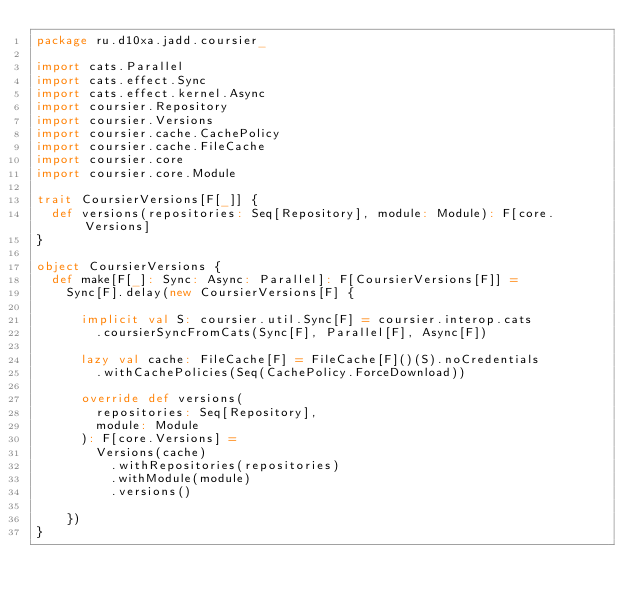<code> <loc_0><loc_0><loc_500><loc_500><_Scala_>package ru.d10xa.jadd.coursier_

import cats.Parallel
import cats.effect.Sync
import cats.effect.kernel.Async
import coursier.Repository
import coursier.Versions
import coursier.cache.CachePolicy
import coursier.cache.FileCache
import coursier.core
import coursier.core.Module

trait CoursierVersions[F[_]] {
  def versions(repositories: Seq[Repository], module: Module): F[core.Versions]
}

object CoursierVersions {
  def make[F[_]: Sync: Async: Parallel]: F[CoursierVersions[F]] =
    Sync[F].delay(new CoursierVersions[F] {

      implicit val S: coursier.util.Sync[F] = coursier.interop.cats
        .coursierSyncFromCats(Sync[F], Parallel[F], Async[F])

      lazy val cache: FileCache[F] = FileCache[F]()(S).noCredentials
        .withCachePolicies(Seq(CachePolicy.ForceDownload))

      override def versions(
        repositories: Seq[Repository],
        module: Module
      ): F[core.Versions] =
        Versions(cache)
          .withRepositories(repositories)
          .withModule(module)
          .versions()

    })
}
</code> 